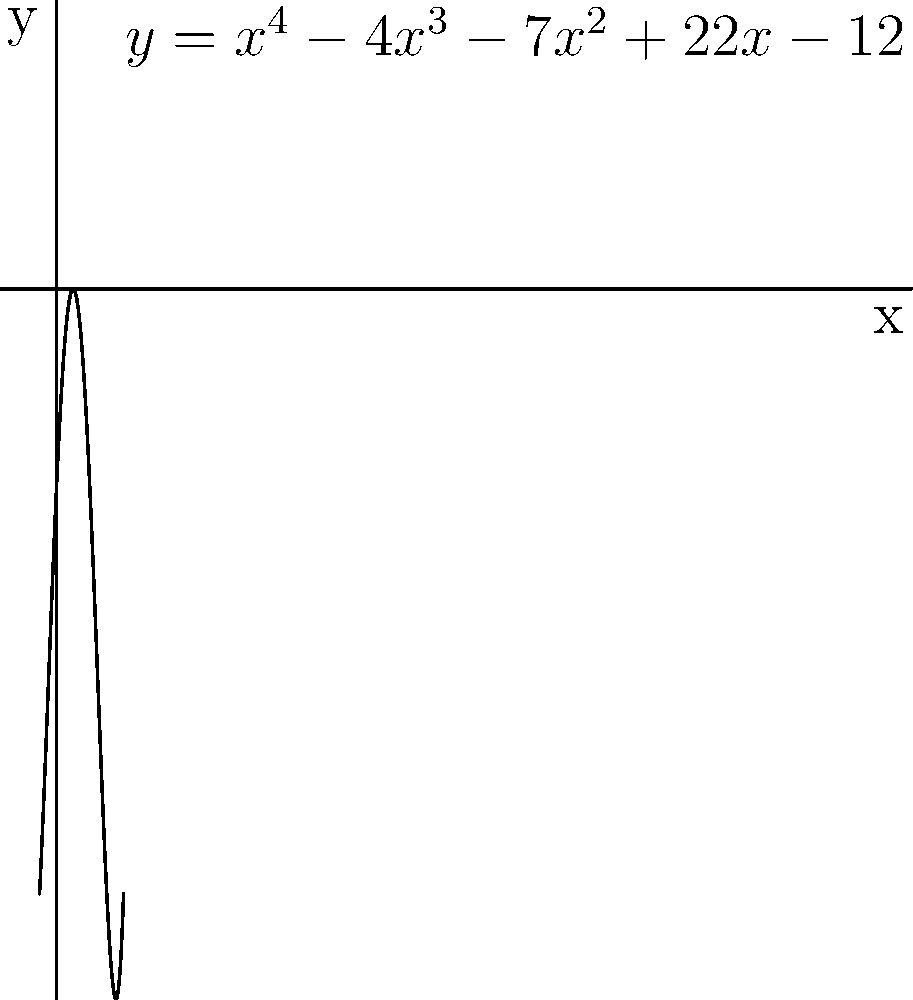The graph above shows a quartic polynomial $f(x) = x^4 - 4x^3 - 7x^2 + 22x - 12$. Using the graph, determine how many real roots the polynomial has and estimate their values. Then, explain how you can verify that these are indeed the roots of the polynomial. To solve this problem, we'll follow these steps:

1) Observe the graph:
   The graph intersects the x-axis at four points. This means the polynomial has four real roots.

2) Estimate the roots:
   The x-intercepts occur approximately at:
   $x_1 \approx 0.5$
   $x_2 \approx 1$
   $x_3 \approx 2$
   $x_4 \approx 3$

3) Verification method:
   To verify these are roots, we can substitute each value into the polynomial equation:

   $f(x) = x^4 - 4x^3 - 7x^2 + 22x - 12$

   If $f(x) = 0$ or very close to 0 for each x-value, it confirms the root.

4) Example verification (for $x = 1$):
   $f(1) = 1^4 - 4(1)^3 - 7(1)^2 + 22(1) - 12$
         $= 1 - 4 - 7 + 22 - 12$
         $= 0$

   This confirms that 1 is indeed a root.

5) For precise roots:
   Use algebraic methods or a graphing calculator to find exact values:
   $x_1 = 0.5$
   $x_2 = 1$
   $x_3 = 2$
   $x_4 = 3$

By taking detailed notes on graphical approaches and participating in class discussions about polynomial behavior, a diligent student would be well-prepared to analyze and solve such problems.
Answer: Four real roots: approximately 0.5, 1, 2, and 3. 